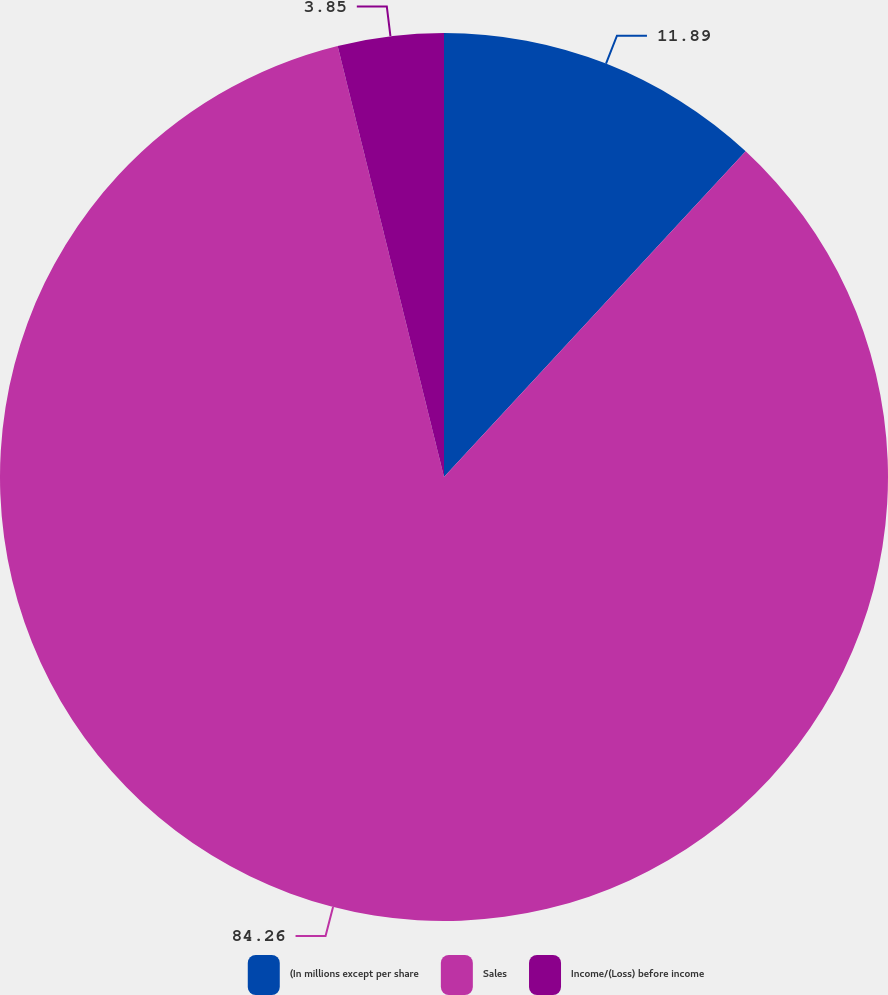Convert chart. <chart><loc_0><loc_0><loc_500><loc_500><pie_chart><fcel>(In millions except per share<fcel>Sales<fcel>Income/(Loss) before income<nl><fcel>11.89%<fcel>84.26%<fcel>3.85%<nl></chart> 